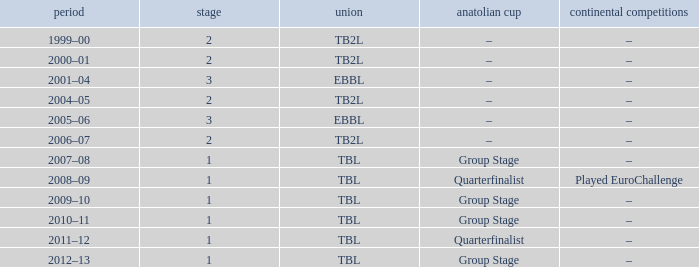Season of 2012–13 is what league? TBL. 